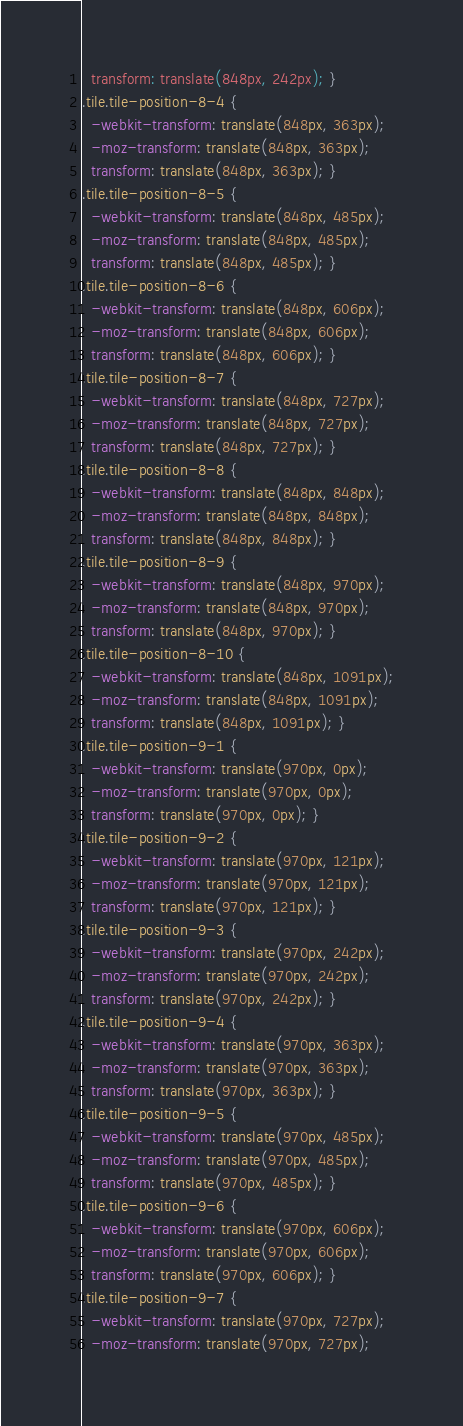<code> <loc_0><loc_0><loc_500><loc_500><_CSS_>  transform: translate(848px, 242px); }
.tile.tile-position-8-4 {
  -webkit-transform: translate(848px, 363px);
  -moz-transform: translate(848px, 363px);
  transform: translate(848px, 363px); }
.tile.tile-position-8-5 {
  -webkit-transform: translate(848px, 485px);
  -moz-transform: translate(848px, 485px);
  transform: translate(848px, 485px); }
.tile.tile-position-8-6 {
  -webkit-transform: translate(848px, 606px);
  -moz-transform: translate(848px, 606px);
  transform: translate(848px, 606px); }
.tile.tile-position-8-7 {
  -webkit-transform: translate(848px, 727px);
  -moz-transform: translate(848px, 727px);
  transform: translate(848px, 727px); }
.tile.tile-position-8-8 {
  -webkit-transform: translate(848px, 848px);
  -moz-transform: translate(848px, 848px);
  transform: translate(848px, 848px); }
.tile.tile-position-8-9 {
  -webkit-transform: translate(848px, 970px);
  -moz-transform: translate(848px, 970px);
  transform: translate(848px, 970px); }
.tile.tile-position-8-10 {
  -webkit-transform: translate(848px, 1091px);
  -moz-transform: translate(848px, 1091px);
  transform: translate(848px, 1091px); }
.tile.tile-position-9-1 {
  -webkit-transform: translate(970px, 0px);
  -moz-transform: translate(970px, 0px);
  transform: translate(970px, 0px); }
.tile.tile-position-9-2 {
  -webkit-transform: translate(970px, 121px);
  -moz-transform: translate(970px, 121px);
  transform: translate(970px, 121px); }
.tile.tile-position-9-3 {
  -webkit-transform: translate(970px, 242px);
  -moz-transform: translate(970px, 242px);
  transform: translate(970px, 242px); }
.tile.tile-position-9-4 {
  -webkit-transform: translate(970px, 363px);
  -moz-transform: translate(970px, 363px);
  transform: translate(970px, 363px); }
.tile.tile-position-9-5 {
  -webkit-transform: translate(970px, 485px);
  -moz-transform: translate(970px, 485px);
  transform: translate(970px, 485px); }
.tile.tile-position-9-6 {
  -webkit-transform: translate(970px, 606px);
  -moz-transform: translate(970px, 606px);
  transform: translate(970px, 606px); }
.tile.tile-position-9-7 {
  -webkit-transform: translate(970px, 727px);
  -moz-transform: translate(970px, 727px);</code> 